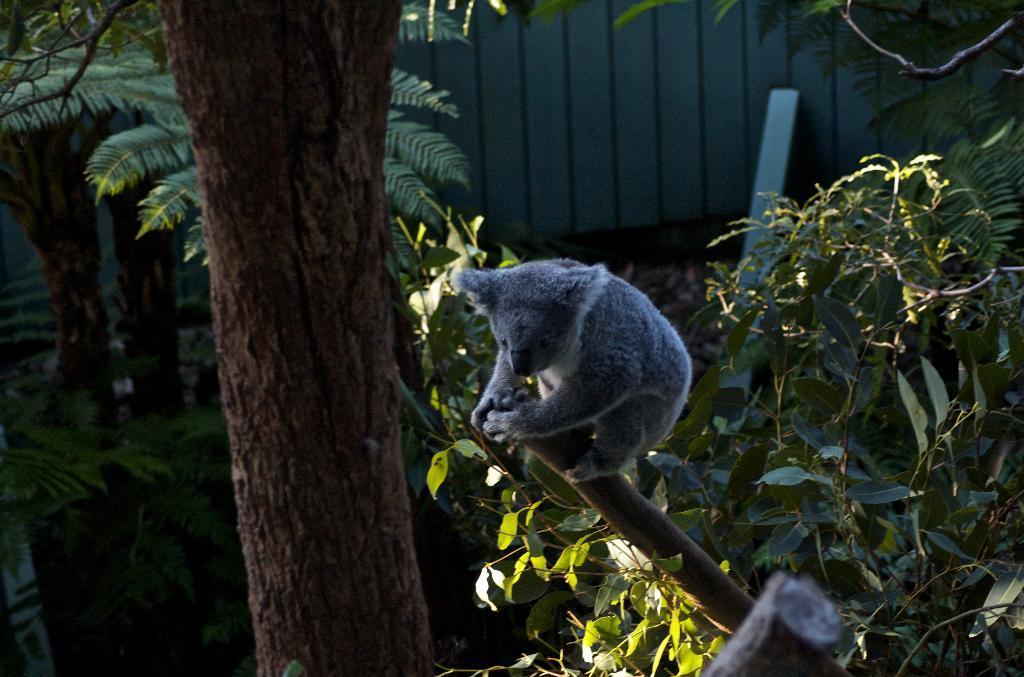Can you describe this image briefly? In this picture I can see an animal is on the tree. In the background I can see wall, an object and trees. 